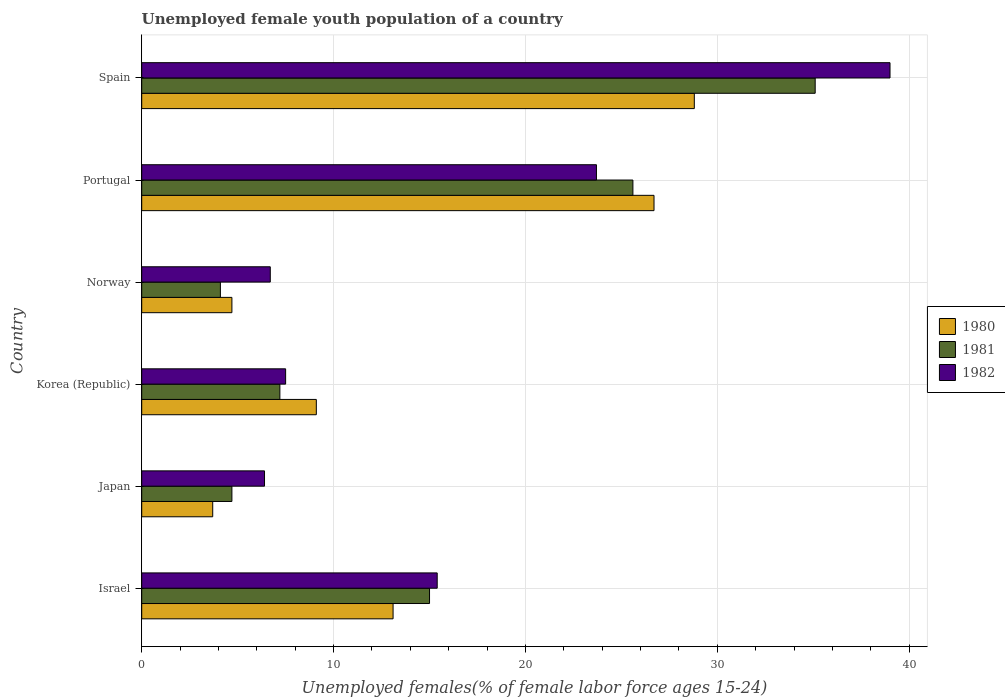Are the number of bars per tick equal to the number of legend labels?
Offer a very short reply. Yes. How many bars are there on the 2nd tick from the bottom?
Give a very brief answer. 3. In how many cases, is the number of bars for a given country not equal to the number of legend labels?
Provide a short and direct response. 0. Across all countries, what is the maximum percentage of unemployed female youth population in 1981?
Your response must be concise. 35.1. Across all countries, what is the minimum percentage of unemployed female youth population in 1981?
Give a very brief answer. 4.1. In which country was the percentage of unemployed female youth population in 1982 minimum?
Ensure brevity in your answer.  Japan. What is the total percentage of unemployed female youth population in 1981 in the graph?
Give a very brief answer. 91.7. What is the difference between the percentage of unemployed female youth population in 1981 in Israel and that in Portugal?
Keep it short and to the point. -10.6. What is the difference between the percentage of unemployed female youth population in 1981 in Portugal and the percentage of unemployed female youth population in 1980 in Korea (Republic)?
Your answer should be compact. 16.5. What is the average percentage of unemployed female youth population in 1981 per country?
Your answer should be compact. 15.28. What is the difference between the percentage of unemployed female youth population in 1980 and percentage of unemployed female youth population in 1981 in Spain?
Your answer should be very brief. -6.3. In how many countries, is the percentage of unemployed female youth population in 1982 greater than 22 %?
Offer a terse response. 2. What is the ratio of the percentage of unemployed female youth population in 1982 in Japan to that in Norway?
Your response must be concise. 0.96. What is the difference between the highest and the second highest percentage of unemployed female youth population in 1980?
Your response must be concise. 2.1. What is the difference between the highest and the lowest percentage of unemployed female youth population in 1981?
Your answer should be very brief. 31. What does the 3rd bar from the top in Spain represents?
Offer a terse response. 1980. What does the 3rd bar from the bottom in Korea (Republic) represents?
Give a very brief answer. 1982. Is it the case that in every country, the sum of the percentage of unemployed female youth population in 1982 and percentage of unemployed female youth population in 1980 is greater than the percentage of unemployed female youth population in 1981?
Your answer should be very brief. Yes. How many bars are there?
Give a very brief answer. 18. What is the difference between two consecutive major ticks on the X-axis?
Ensure brevity in your answer.  10. Are the values on the major ticks of X-axis written in scientific E-notation?
Ensure brevity in your answer.  No. Does the graph contain any zero values?
Ensure brevity in your answer.  No. How are the legend labels stacked?
Provide a succinct answer. Vertical. What is the title of the graph?
Make the answer very short. Unemployed female youth population of a country. Does "1976" appear as one of the legend labels in the graph?
Offer a terse response. No. What is the label or title of the X-axis?
Offer a very short reply. Unemployed females(% of female labor force ages 15-24). What is the label or title of the Y-axis?
Offer a terse response. Country. What is the Unemployed females(% of female labor force ages 15-24) in 1980 in Israel?
Offer a terse response. 13.1. What is the Unemployed females(% of female labor force ages 15-24) of 1981 in Israel?
Your answer should be compact. 15. What is the Unemployed females(% of female labor force ages 15-24) in 1982 in Israel?
Offer a terse response. 15.4. What is the Unemployed females(% of female labor force ages 15-24) in 1980 in Japan?
Offer a very short reply. 3.7. What is the Unemployed females(% of female labor force ages 15-24) of 1981 in Japan?
Provide a short and direct response. 4.7. What is the Unemployed females(% of female labor force ages 15-24) of 1982 in Japan?
Make the answer very short. 6.4. What is the Unemployed females(% of female labor force ages 15-24) of 1980 in Korea (Republic)?
Provide a succinct answer. 9.1. What is the Unemployed females(% of female labor force ages 15-24) in 1981 in Korea (Republic)?
Keep it short and to the point. 7.2. What is the Unemployed females(% of female labor force ages 15-24) of 1980 in Norway?
Offer a terse response. 4.7. What is the Unemployed females(% of female labor force ages 15-24) in 1981 in Norway?
Offer a terse response. 4.1. What is the Unemployed females(% of female labor force ages 15-24) of 1982 in Norway?
Give a very brief answer. 6.7. What is the Unemployed females(% of female labor force ages 15-24) in 1980 in Portugal?
Your answer should be compact. 26.7. What is the Unemployed females(% of female labor force ages 15-24) of 1981 in Portugal?
Provide a short and direct response. 25.6. What is the Unemployed females(% of female labor force ages 15-24) in 1982 in Portugal?
Your answer should be compact. 23.7. What is the Unemployed females(% of female labor force ages 15-24) in 1980 in Spain?
Make the answer very short. 28.8. What is the Unemployed females(% of female labor force ages 15-24) of 1981 in Spain?
Make the answer very short. 35.1. What is the Unemployed females(% of female labor force ages 15-24) of 1982 in Spain?
Your response must be concise. 39. Across all countries, what is the maximum Unemployed females(% of female labor force ages 15-24) in 1980?
Your response must be concise. 28.8. Across all countries, what is the maximum Unemployed females(% of female labor force ages 15-24) of 1981?
Your answer should be very brief. 35.1. Across all countries, what is the maximum Unemployed females(% of female labor force ages 15-24) in 1982?
Ensure brevity in your answer.  39. Across all countries, what is the minimum Unemployed females(% of female labor force ages 15-24) of 1980?
Offer a terse response. 3.7. Across all countries, what is the minimum Unemployed females(% of female labor force ages 15-24) of 1981?
Keep it short and to the point. 4.1. Across all countries, what is the minimum Unemployed females(% of female labor force ages 15-24) in 1982?
Make the answer very short. 6.4. What is the total Unemployed females(% of female labor force ages 15-24) in 1980 in the graph?
Ensure brevity in your answer.  86.1. What is the total Unemployed females(% of female labor force ages 15-24) in 1981 in the graph?
Offer a very short reply. 91.7. What is the total Unemployed females(% of female labor force ages 15-24) in 1982 in the graph?
Give a very brief answer. 98.7. What is the difference between the Unemployed females(% of female labor force ages 15-24) of 1980 in Israel and that in Japan?
Offer a terse response. 9.4. What is the difference between the Unemployed females(% of female labor force ages 15-24) of 1982 in Israel and that in Japan?
Your response must be concise. 9. What is the difference between the Unemployed females(% of female labor force ages 15-24) in 1981 in Israel and that in Korea (Republic)?
Ensure brevity in your answer.  7.8. What is the difference between the Unemployed females(% of female labor force ages 15-24) in 1982 in Israel and that in Korea (Republic)?
Provide a short and direct response. 7.9. What is the difference between the Unemployed females(% of female labor force ages 15-24) in 1980 in Israel and that in Portugal?
Keep it short and to the point. -13.6. What is the difference between the Unemployed females(% of female labor force ages 15-24) of 1981 in Israel and that in Portugal?
Give a very brief answer. -10.6. What is the difference between the Unemployed females(% of female labor force ages 15-24) in 1982 in Israel and that in Portugal?
Your answer should be compact. -8.3. What is the difference between the Unemployed females(% of female labor force ages 15-24) in 1980 in Israel and that in Spain?
Provide a short and direct response. -15.7. What is the difference between the Unemployed females(% of female labor force ages 15-24) in 1981 in Israel and that in Spain?
Make the answer very short. -20.1. What is the difference between the Unemployed females(% of female labor force ages 15-24) of 1982 in Israel and that in Spain?
Provide a succinct answer. -23.6. What is the difference between the Unemployed females(% of female labor force ages 15-24) of 1980 in Japan and that in Korea (Republic)?
Your response must be concise. -5.4. What is the difference between the Unemployed females(% of female labor force ages 15-24) in 1982 in Japan and that in Korea (Republic)?
Offer a very short reply. -1.1. What is the difference between the Unemployed females(% of female labor force ages 15-24) in 1980 in Japan and that in Norway?
Make the answer very short. -1. What is the difference between the Unemployed females(% of female labor force ages 15-24) of 1982 in Japan and that in Norway?
Offer a terse response. -0.3. What is the difference between the Unemployed females(% of female labor force ages 15-24) of 1980 in Japan and that in Portugal?
Give a very brief answer. -23. What is the difference between the Unemployed females(% of female labor force ages 15-24) of 1981 in Japan and that in Portugal?
Your response must be concise. -20.9. What is the difference between the Unemployed females(% of female labor force ages 15-24) in 1982 in Japan and that in Portugal?
Provide a short and direct response. -17.3. What is the difference between the Unemployed females(% of female labor force ages 15-24) in 1980 in Japan and that in Spain?
Your answer should be very brief. -25.1. What is the difference between the Unemployed females(% of female labor force ages 15-24) in 1981 in Japan and that in Spain?
Offer a very short reply. -30.4. What is the difference between the Unemployed females(% of female labor force ages 15-24) in 1982 in Japan and that in Spain?
Provide a succinct answer. -32.6. What is the difference between the Unemployed females(% of female labor force ages 15-24) in 1980 in Korea (Republic) and that in Norway?
Offer a very short reply. 4.4. What is the difference between the Unemployed females(% of female labor force ages 15-24) in 1980 in Korea (Republic) and that in Portugal?
Your response must be concise. -17.6. What is the difference between the Unemployed females(% of female labor force ages 15-24) of 1981 in Korea (Republic) and that in Portugal?
Provide a short and direct response. -18.4. What is the difference between the Unemployed females(% of female labor force ages 15-24) in 1982 in Korea (Republic) and that in Portugal?
Make the answer very short. -16.2. What is the difference between the Unemployed females(% of female labor force ages 15-24) of 1980 in Korea (Republic) and that in Spain?
Keep it short and to the point. -19.7. What is the difference between the Unemployed females(% of female labor force ages 15-24) in 1981 in Korea (Republic) and that in Spain?
Provide a succinct answer. -27.9. What is the difference between the Unemployed females(% of female labor force ages 15-24) in 1982 in Korea (Republic) and that in Spain?
Offer a very short reply. -31.5. What is the difference between the Unemployed females(% of female labor force ages 15-24) of 1980 in Norway and that in Portugal?
Provide a succinct answer. -22. What is the difference between the Unemployed females(% of female labor force ages 15-24) in 1981 in Norway and that in Portugal?
Your response must be concise. -21.5. What is the difference between the Unemployed females(% of female labor force ages 15-24) in 1980 in Norway and that in Spain?
Give a very brief answer. -24.1. What is the difference between the Unemployed females(% of female labor force ages 15-24) of 1981 in Norway and that in Spain?
Your answer should be very brief. -31. What is the difference between the Unemployed females(% of female labor force ages 15-24) of 1982 in Norway and that in Spain?
Offer a very short reply. -32.3. What is the difference between the Unemployed females(% of female labor force ages 15-24) of 1980 in Portugal and that in Spain?
Provide a short and direct response. -2.1. What is the difference between the Unemployed females(% of female labor force ages 15-24) in 1982 in Portugal and that in Spain?
Ensure brevity in your answer.  -15.3. What is the difference between the Unemployed females(% of female labor force ages 15-24) in 1981 in Israel and the Unemployed females(% of female labor force ages 15-24) in 1982 in Japan?
Offer a very short reply. 8.6. What is the difference between the Unemployed females(% of female labor force ages 15-24) of 1980 in Israel and the Unemployed females(% of female labor force ages 15-24) of 1981 in Korea (Republic)?
Make the answer very short. 5.9. What is the difference between the Unemployed females(% of female labor force ages 15-24) of 1980 in Israel and the Unemployed females(% of female labor force ages 15-24) of 1982 in Portugal?
Offer a very short reply. -10.6. What is the difference between the Unemployed females(% of female labor force ages 15-24) of 1981 in Israel and the Unemployed females(% of female labor force ages 15-24) of 1982 in Portugal?
Ensure brevity in your answer.  -8.7. What is the difference between the Unemployed females(% of female labor force ages 15-24) of 1980 in Israel and the Unemployed females(% of female labor force ages 15-24) of 1982 in Spain?
Provide a succinct answer. -25.9. What is the difference between the Unemployed females(% of female labor force ages 15-24) in 1981 in Israel and the Unemployed females(% of female labor force ages 15-24) in 1982 in Spain?
Your answer should be very brief. -24. What is the difference between the Unemployed females(% of female labor force ages 15-24) of 1980 in Japan and the Unemployed females(% of female labor force ages 15-24) of 1981 in Portugal?
Keep it short and to the point. -21.9. What is the difference between the Unemployed females(% of female labor force ages 15-24) of 1980 in Japan and the Unemployed females(% of female labor force ages 15-24) of 1981 in Spain?
Offer a very short reply. -31.4. What is the difference between the Unemployed females(% of female labor force ages 15-24) in 1980 in Japan and the Unemployed females(% of female labor force ages 15-24) in 1982 in Spain?
Offer a terse response. -35.3. What is the difference between the Unemployed females(% of female labor force ages 15-24) of 1981 in Japan and the Unemployed females(% of female labor force ages 15-24) of 1982 in Spain?
Provide a short and direct response. -34.3. What is the difference between the Unemployed females(% of female labor force ages 15-24) of 1980 in Korea (Republic) and the Unemployed females(% of female labor force ages 15-24) of 1981 in Portugal?
Make the answer very short. -16.5. What is the difference between the Unemployed females(% of female labor force ages 15-24) in 1980 in Korea (Republic) and the Unemployed females(% of female labor force ages 15-24) in 1982 in Portugal?
Ensure brevity in your answer.  -14.6. What is the difference between the Unemployed females(% of female labor force ages 15-24) in 1981 in Korea (Republic) and the Unemployed females(% of female labor force ages 15-24) in 1982 in Portugal?
Keep it short and to the point. -16.5. What is the difference between the Unemployed females(% of female labor force ages 15-24) in 1980 in Korea (Republic) and the Unemployed females(% of female labor force ages 15-24) in 1982 in Spain?
Offer a terse response. -29.9. What is the difference between the Unemployed females(% of female labor force ages 15-24) in 1981 in Korea (Republic) and the Unemployed females(% of female labor force ages 15-24) in 1982 in Spain?
Make the answer very short. -31.8. What is the difference between the Unemployed females(% of female labor force ages 15-24) of 1980 in Norway and the Unemployed females(% of female labor force ages 15-24) of 1981 in Portugal?
Provide a short and direct response. -20.9. What is the difference between the Unemployed females(% of female labor force ages 15-24) in 1981 in Norway and the Unemployed females(% of female labor force ages 15-24) in 1982 in Portugal?
Make the answer very short. -19.6. What is the difference between the Unemployed females(% of female labor force ages 15-24) of 1980 in Norway and the Unemployed females(% of female labor force ages 15-24) of 1981 in Spain?
Ensure brevity in your answer.  -30.4. What is the difference between the Unemployed females(% of female labor force ages 15-24) in 1980 in Norway and the Unemployed females(% of female labor force ages 15-24) in 1982 in Spain?
Your answer should be compact. -34.3. What is the difference between the Unemployed females(% of female labor force ages 15-24) of 1981 in Norway and the Unemployed females(% of female labor force ages 15-24) of 1982 in Spain?
Your answer should be very brief. -34.9. What is the difference between the Unemployed females(% of female labor force ages 15-24) in 1980 in Portugal and the Unemployed females(% of female labor force ages 15-24) in 1981 in Spain?
Make the answer very short. -8.4. What is the difference between the Unemployed females(% of female labor force ages 15-24) of 1981 in Portugal and the Unemployed females(% of female labor force ages 15-24) of 1982 in Spain?
Keep it short and to the point. -13.4. What is the average Unemployed females(% of female labor force ages 15-24) of 1980 per country?
Provide a succinct answer. 14.35. What is the average Unemployed females(% of female labor force ages 15-24) of 1981 per country?
Ensure brevity in your answer.  15.28. What is the average Unemployed females(% of female labor force ages 15-24) of 1982 per country?
Your response must be concise. 16.45. What is the difference between the Unemployed females(% of female labor force ages 15-24) of 1980 and Unemployed females(% of female labor force ages 15-24) of 1982 in Israel?
Offer a very short reply. -2.3. What is the difference between the Unemployed females(% of female labor force ages 15-24) of 1981 and Unemployed females(% of female labor force ages 15-24) of 1982 in Israel?
Provide a short and direct response. -0.4. What is the difference between the Unemployed females(% of female labor force ages 15-24) of 1980 and Unemployed females(% of female labor force ages 15-24) of 1981 in Japan?
Provide a succinct answer. -1. What is the difference between the Unemployed females(% of female labor force ages 15-24) in 1980 and Unemployed females(% of female labor force ages 15-24) in 1982 in Japan?
Ensure brevity in your answer.  -2.7. What is the difference between the Unemployed females(% of female labor force ages 15-24) of 1981 and Unemployed females(% of female labor force ages 15-24) of 1982 in Korea (Republic)?
Provide a short and direct response. -0.3. What is the difference between the Unemployed females(% of female labor force ages 15-24) in 1980 and Unemployed females(% of female labor force ages 15-24) in 1981 in Norway?
Offer a very short reply. 0.6. What is the difference between the Unemployed females(% of female labor force ages 15-24) of 1980 and Unemployed females(% of female labor force ages 15-24) of 1982 in Portugal?
Your response must be concise. 3. What is the difference between the Unemployed females(% of female labor force ages 15-24) in 1980 and Unemployed females(% of female labor force ages 15-24) in 1981 in Spain?
Offer a very short reply. -6.3. What is the difference between the Unemployed females(% of female labor force ages 15-24) in 1980 and Unemployed females(% of female labor force ages 15-24) in 1982 in Spain?
Ensure brevity in your answer.  -10.2. What is the ratio of the Unemployed females(% of female labor force ages 15-24) in 1980 in Israel to that in Japan?
Offer a terse response. 3.54. What is the ratio of the Unemployed females(% of female labor force ages 15-24) in 1981 in Israel to that in Japan?
Make the answer very short. 3.19. What is the ratio of the Unemployed females(% of female labor force ages 15-24) in 1982 in Israel to that in Japan?
Your answer should be very brief. 2.41. What is the ratio of the Unemployed females(% of female labor force ages 15-24) of 1980 in Israel to that in Korea (Republic)?
Make the answer very short. 1.44. What is the ratio of the Unemployed females(% of female labor force ages 15-24) in 1981 in Israel to that in Korea (Republic)?
Provide a succinct answer. 2.08. What is the ratio of the Unemployed females(% of female labor force ages 15-24) of 1982 in Israel to that in Korea (Republic)?
Offer a very short reply. 2.05. What is the ratio of the Unemployed females(% of female labor force ages 15-24) in 1980 in Israel to that in Norway?
Offer a terse response. 2.79. What is the ratio of the Unemployed females(% of female labor force ages 15-24) in 1981 in Israel to that in Norway?
Make the answer very short. 3.66. What is the ratio of the Unemployed females(% of female labor force ages 15-24) in 1982 in Israel to that in Norway?
Keep it short and to the point. 2.3. What is the ratio of the Unemployed females(% of female labor force ages 15-24) of 1980 in Israel to that in Portugal?
Offer a very short reply. 0.49. What is the ratio of the Unemployed females(% of female labor force ages 15-24) in 1981 in Israel to that in Portugal?
Your answer should be very brief. 0.59. What is the ratio of the Unemployed females(% of female labor force ages 15-24) of 1982 in Israel to that in Portugal?
Ensure brevity in your answer.  0.65. What is the ratio of the Unemployed females(% of female labor force ages 15-24) of 1980 in Israel to that in Spain?
Offer a terse response. 0.45. What is the ratio of the Unemployed females(% of female labor force ages 15-24) in 1981 in Israel to that in Spain?
Keep it short and to the point. 0.43. What is the ratio of the Unemployed females(% of female labor force ages 15-24) of 1982 in Israel to that in Spain?
Provide a short and direct response. 0.39. What is the ratio of the Unemployed females(% of female labor force ages 15-24) in 1980 in Japan to that in Korea (Republic)?
Your answer should be compact. 0.41. What is the ratio of the Unemployed females(% of female labor force ages 15-24) of 1981 in Japan to that in Korea (Republic)?
Keep it short and to the point. 0.65. What is the ratio of the Unemployed females(% of female labor force ages 15-24) in 1982 in Japan to that in Korea (Republic)?
Offer a very short reply. 0.85. What is the ratio of the Unemployed females(% of female labor force ages 15-24) of 1980 in Japan to that in Norway?
Offer a terse response. 0.79. What is the ratio of the Unemployed females(% of female labor force ages 15-24) of 1981 in Japan to that in Norway?
Your response must be concise. 1.15. What is the ratio of the Unemployed females(% of female labor force ages 15-24) of 1982 in Japan to that in Norway?
Provide a short and direct response. 0.96. What is the ratio of the Unemployed females(% of female labor force ages 15-24) in 1980 in Japan to that in Portugal?
Your answer should be very brief. 0.14. What is the ratio of the Unemployed females(% of female labor force ages 15-24) of 1981 in Japan to that in Portugal?
Offer a terse response. 0.18. What is the ratio of the Unemployed females(% of female labor force ages 15-24) of 1982 in Japan to that in Portugal?
Provide a short and direct response. 0.27. What is the ratio of the Unemployed females(% of female labor force ages 15-24) of 1980 in Japan to that in Spain?
Offer a very short reply. 0.13. What is the ratio of the Unemployed females(% of female labor force ages 15-24) in 1981 in Japan to that in Spain?
Make the answer very short. 0.13. What is the ratio of the Unemployed females(% of female labor force ages 15-24) in 1982 in Japan to that in Spain?
Your answer should be very brief. 0.16. What is the ratio of the Unemployed females(% of female labor force ages 15-24) of 1980 in Korea (Republic) to that in Norway?
Your answer should be very brief. 1.94. What is the ratio of the Unemployed females(% of female labor force ages 15-24) in 1981 in Korea (Republic) to that in Norway?
Give a very brief answer. 1.76. What is the ratio of the Unemployed females(% of female labor force ages 15-24) of 1982 in Korea (Republic) to that in Norway?
Give a very brief answer. 1.12. What is the ratio of the Unemployed females(% of female labor force ages 15-24) of 1980 in Korea (Republic) to that in Portugal?
Make the answer very short. 0.34. What is the ratio of the Unemployed females(% of female labor force ages 15-24) of 1981 in Korea (Republic) to that in Portugal?
Offer a very short reply. 0.28. What is the ratio of the Unemployed females(% of female labor force ages 15-24) in 1982 in Korea (Republic) to that in Portugal?
Keep it short and to the point. 0.32. What is the ratio of the Unemployed females(% of female labor force ages 15-24) of 1980 in Korea (Republic) to that in Spain?
Your answer should be very brief. 0.32. What is the ratio of the Unemployed females(% of female labor force ages 15-24) in 1981 in Korea (Republic) to that in Spain?
Provide a succinct answer. 0.21. What is the ratio of the Unemployed females(% of female labor force ages 15-24) of 1982 in Korea (Republic) to that in Spain?
Ensure brevity in your answer.  0.19. What is the ratio of the Unemployed females(% of female labor force ages 15-24) of 1980 in Norway to that in Portugal?
Keep it short and to the point. 0.18. What is the ratio of the Unemployed females(% of female labor force ages 15-24) of 1981 in Norway to that in Portugal?
Your answer should be compact. 0.16. What is the ratio of the Unemployed females(% of female labor force ages 15-24) in 1982 in Norway to that in Portugal?
Give a very brief answer. 0.28. What is the ratio of the Unemployed females(% of female labor force ages 15-24) of 1980 in Norway to that in Spain?
Provide a succinct answer. 0.16. What is the ratio of the Unemployed females(% of female labor force ages 15-24) of 1981 in Norway to that in Spain?
Make the answer very short. 0.12. What is the ratio of the Unemployed females(% of female labor force ages 15-24) in 1982 in Norway to that in Spain?
Offer a terse response. 0.17. What is the ratio of the Unemployed females(% of female labor force ages 15-24) in 1980 in Portugal to that in Spain?
Your response must be concise. 0.93. What is the ratio of the Unemployed females(% of female labor force ages 15-24) in 1981 in Portugal to that in Spain?
Make the answer very short. 0.73. What is the ratio of the Unemployed females(% of female labor force ages 15-24) of 1982 in Portugal to that in Spain?
Your response must be concise. 0.61. What is the difference between the highest and the lowest Unemployed females(% of female labor force ages 15-24) in 1980?
Make the answer very short. 25.1. What is the difference between the highest and the lowest Unemployed females(% of female labor force ages 15-24) of 1981?
Provide a succinct answer. 31. What is the difference between the highest and the lowest Unemployed females(% of female labor force ages 15-24) in 1982?
Keep it short and to the point. 32.6. 